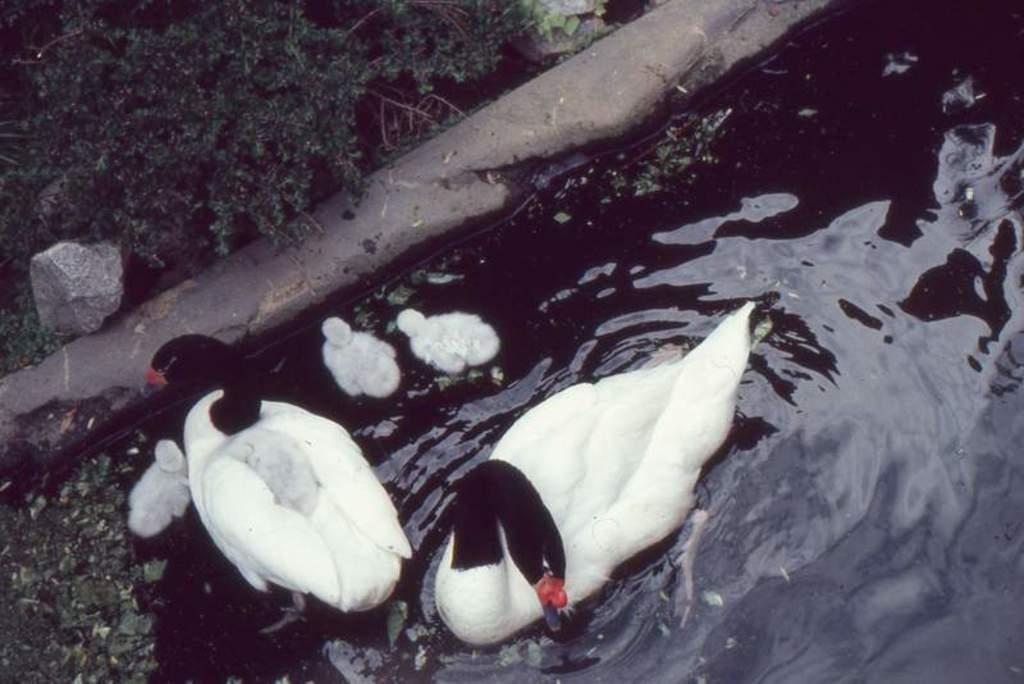Could you give a brief overview of what you see in this image? In this image we can see ducks and ducklings in the water. Near to that there is a stone. Also there are plants. 